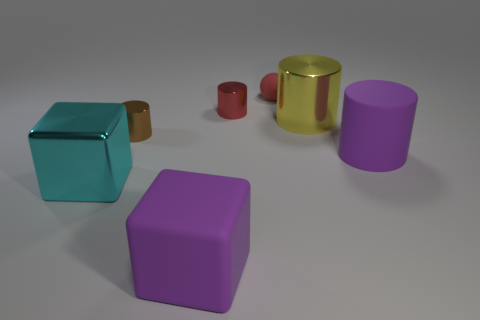Are any tiny red metal things visible?
Your answer should be compact. Yes. What is the size of the matte object that is both left of the large yellow object and behind the large purple block?
Offer a very short reply. Small. Are there more tiny brown cylinders in front of the tiny brown object than rubber cylinders to the left of the cyan metallic block?
Your answer should be compact. No. There is a metallic cylinder that is the same color as the ball; what size is it?
Give a very brief answer. Small. The big metal cylinder has what color?
Ensure brevity in your answer.  Yellow. There is a shiny object that is both right of the rubber block and to the left of the rubber ball; what is its color?
Provide a short and direct response. Red. There is a tiny cylinder in front of the large metal object that is right of the large purple matte thing in front of the large metallic cube; what is its color?
Your answer should be compact. Brown. There is another block that is the same size as the purple cube; what is its color?
Provide a succinct answer. Cyan. What shape is the large object that is left of the tiny metallic object that is to the left of the big object that is in front of the cyan block?
Your response must be concise. Cube. There is a tiny metal thing that is the same color as the ball; what shape is it?
Keep it short and to the point. Cylinder. 